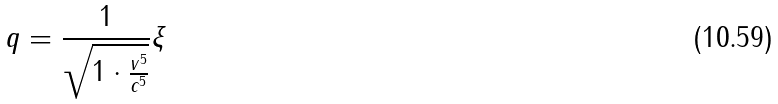Convert formula to latex. <formula><loc_0><loc_0><loc_500><loc_500>q = \frac { 1 } { \sqrt { 1 \cdot \frac { v ^ { 5 } } { c ^ { 5 } } } } \xi</formula> 